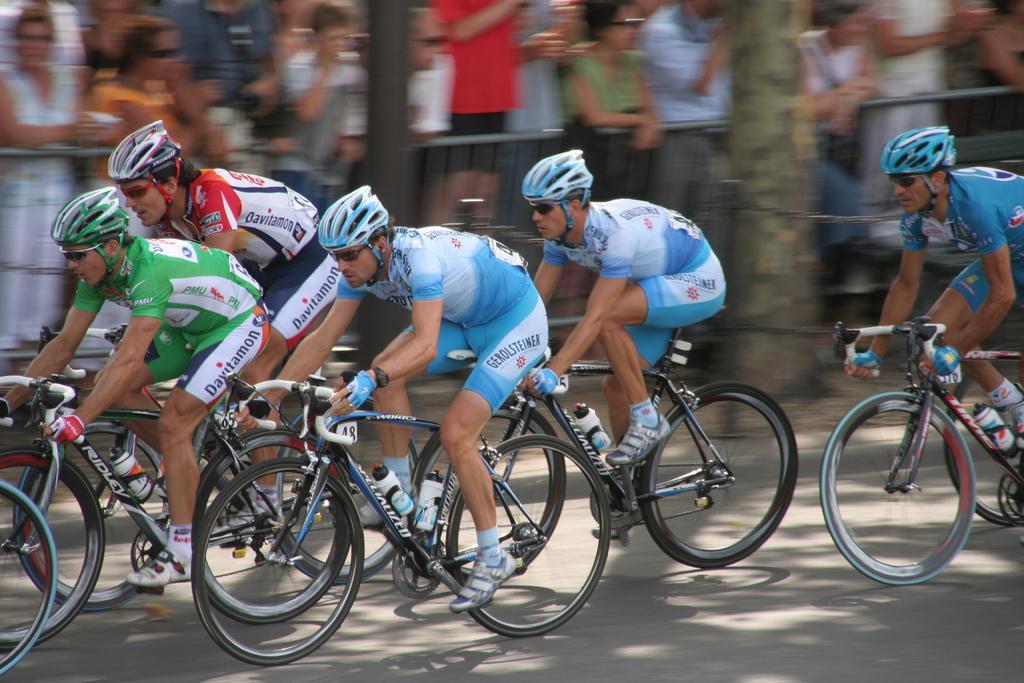How would you summarize this image in a sentence or two? In this picture there are men riding bicycles on the road and wore helmets. In the background of the image it is blurry and we can see people, tree trunk, fence and pole. 